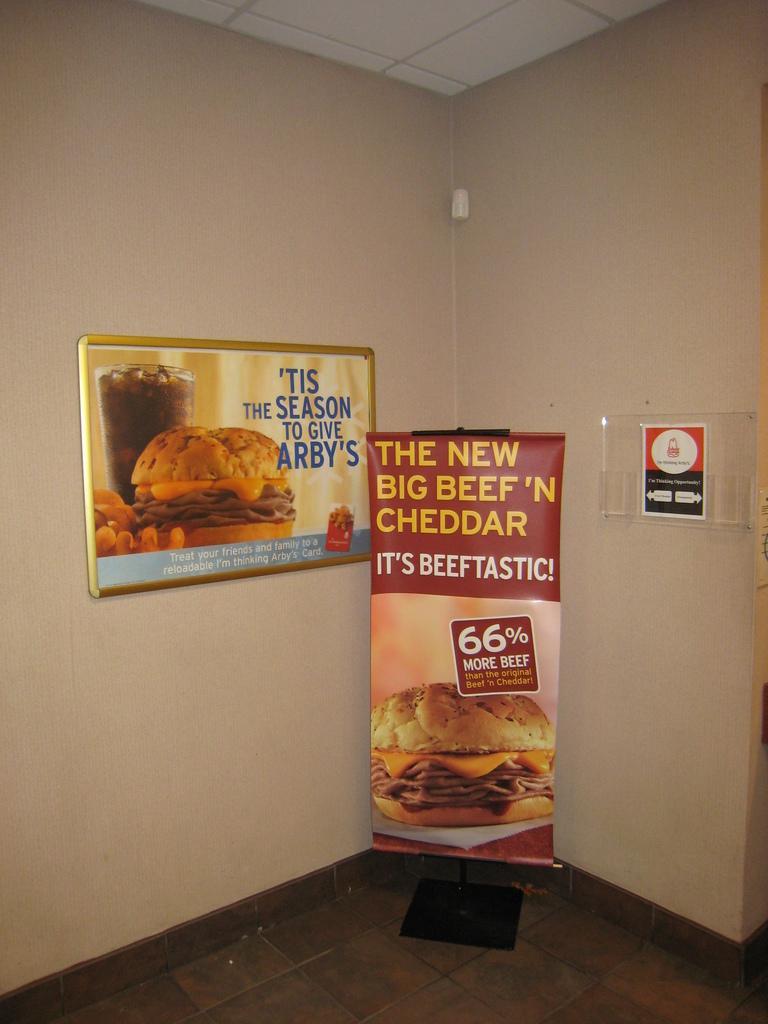How would you summarize this image in a sentence or two? In this image we can see there is a banner with image and text written on it. And at the back there is a wall. And to the wall there is a glass and board attached to it. 